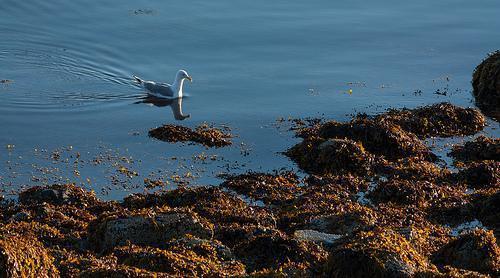How many birds are there?
Give a very brief answer. 1. 